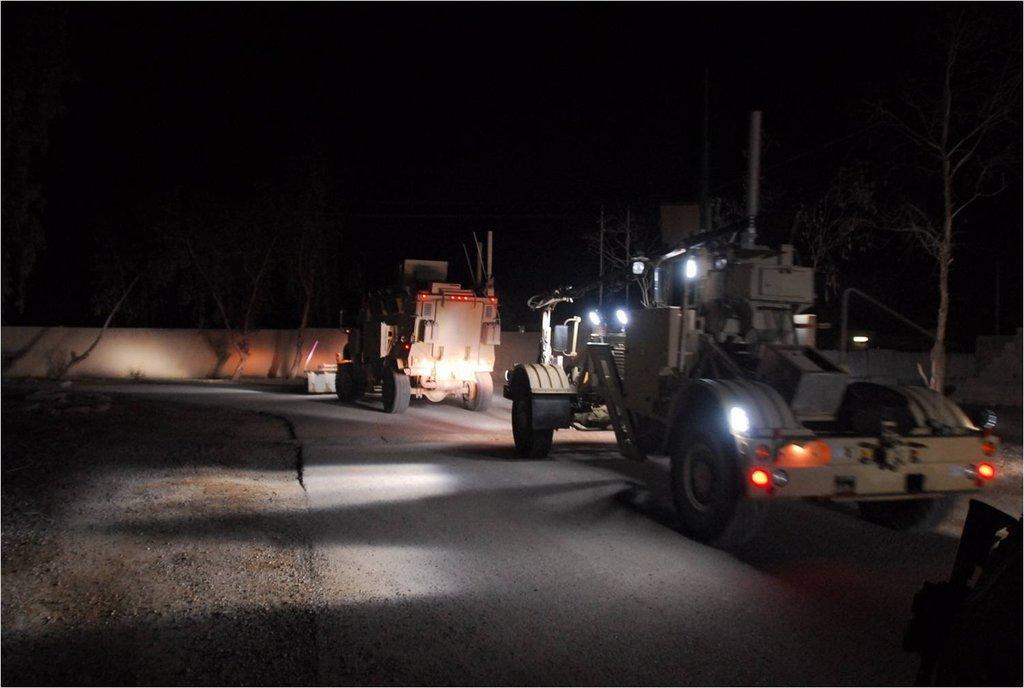Can you describe this image briefly? Here we can see vehicles on the road. There are trees, poles, lights, and a wall. There is a dark background. 